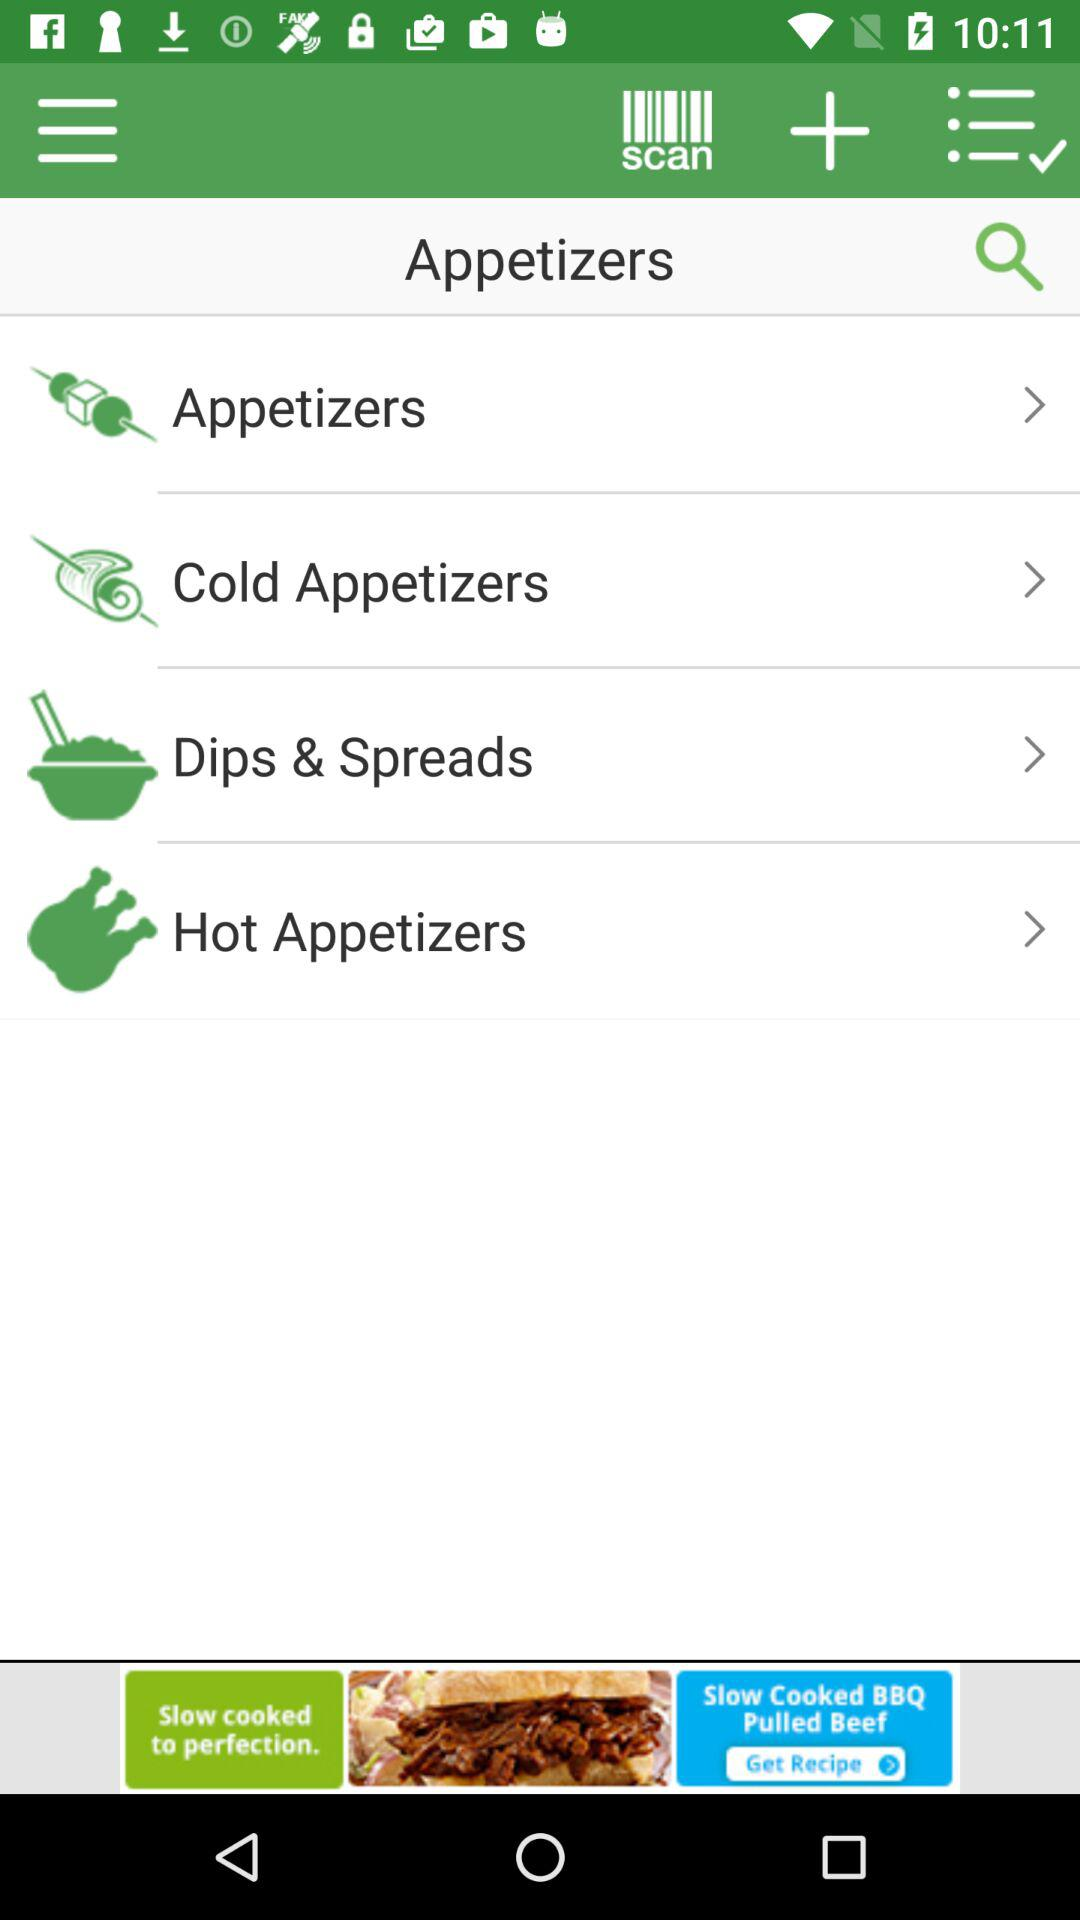How many items are in the appetizers section?
Answer the question using a single word or phrase. 4 